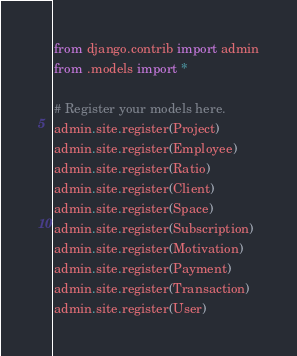<code> <loc_0><loc_0><loc_500><loc_500><_Python_>from django.contrib import admin
from .models import *

# Register your models here.
admin.site.register(Project)
admin.site.register(Employee)
admin.site.register(Ratio)
admin.site.register(Client)
admin.site.register(Space)
admin.site.register(Subscription)
admin.site.register(Motivation)
admin.site.register(Payment)
admin.site.register(Transaction)
admin.site.register(User)

</code> 